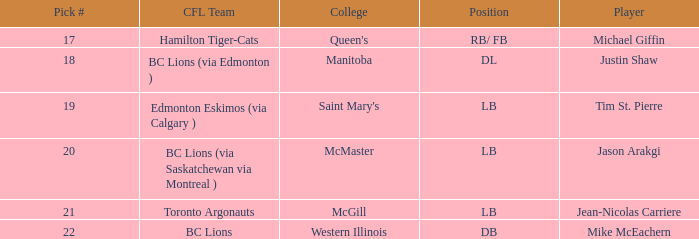What position is Justin Shaw in? DL. 